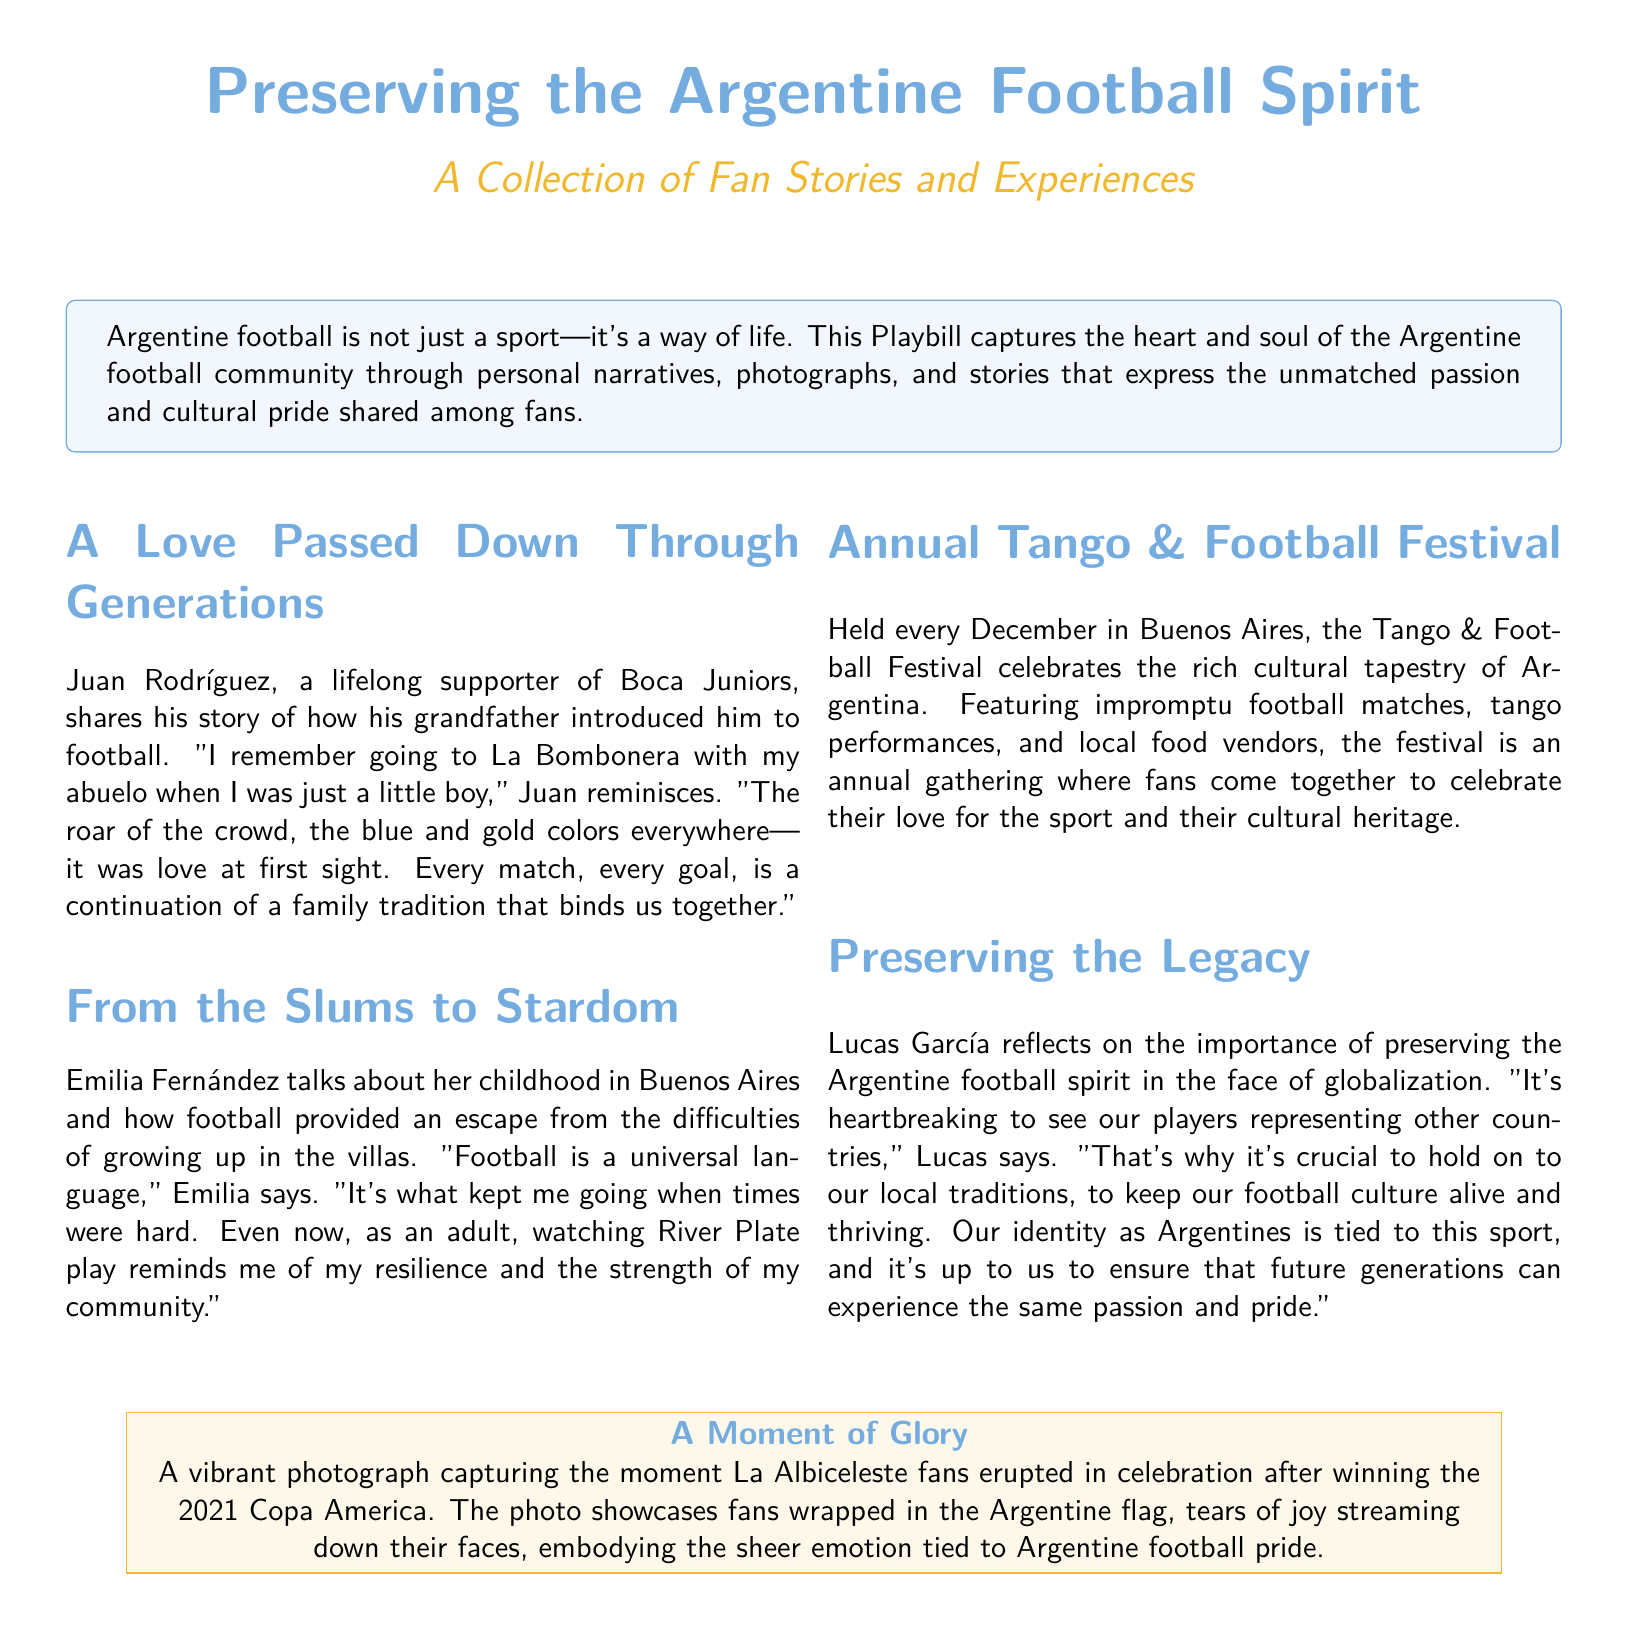What event is celebrated annually in December? The Tango & Football Festival is celebrated annually in December in Buenos Aires.
Answer: Tango & Football Festival Who shares their story about watching River Plate? Emilia Fernández talks about her childhood in Buenos Aires and watching River Plate play.
Answer: Emilia Fernández What does Lucas García emphasize is important for future generations? Lucas García emphasizes the importance of preserving the Argentine football spirit for future generations.
Answer: Preserving the Argentine football spirit Which team did Juan Rodríguez support? Juan Rodríguez is a lifelong supporter of Boca Juniors.
Answer: Boca Juniors What significant victory is captured in a photograph? The photograph captures the moment La Albiceleste fans celebrated after winning the 2021 Copa America.
Answer: 2021 Copa America 